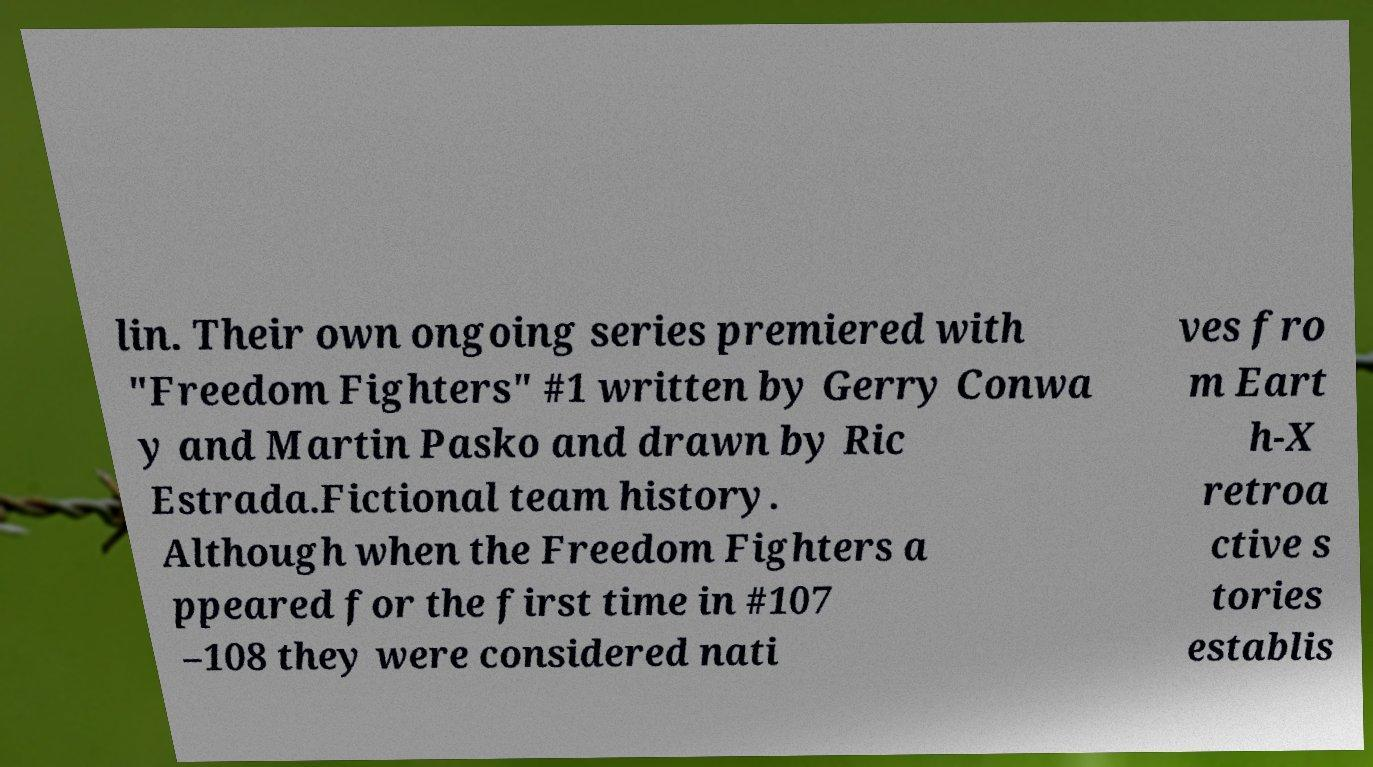There's text embedded in this image that I need extracted. Can you transcribe it verbatim? lin. Their own ongoing series premiered with "Freedom Fighters" #1 written by Gerry Conwa y and Martin Pasko and drawn by Ric Estrada.Fictional team history. Although when the Freedom Fighters a ppeared for the first time in #107 –108 they were considered nati ves fro m Eart h-X retroa ctive s tories establis 